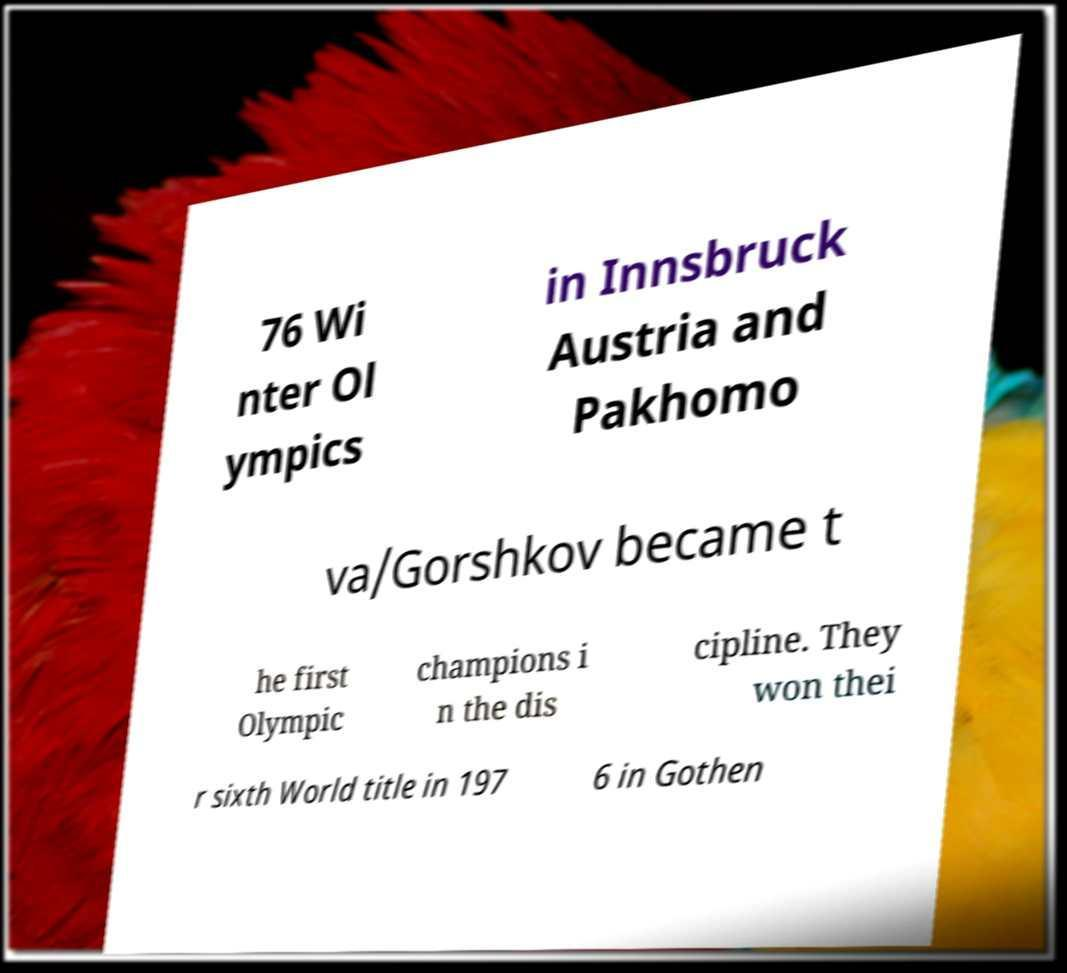Please read and relay the text visible in this image. What does it say? 76 Wi nter Ol ympics in Innsbruck Austria and Pakhomo va/Gorshkov became t he first Olympic champions i n the dis cipline. They won thei r sixth World title in 197 6 in Gothen 